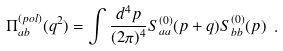<formula> <loc_0><loc_0><loc_500><loc_500>\Pi _ { a b } ^ { ( p o l ) } ( q ^ { 2 } ) = \int \frac { d ^ { 4 } p } { ( 2 \pi ) ^ { 4 } } S _ { a a } ^ { ( 0 ) } ( p + q ) S _ { b b } ^ { ( 0 ) } ( p ) \ .</formula> 